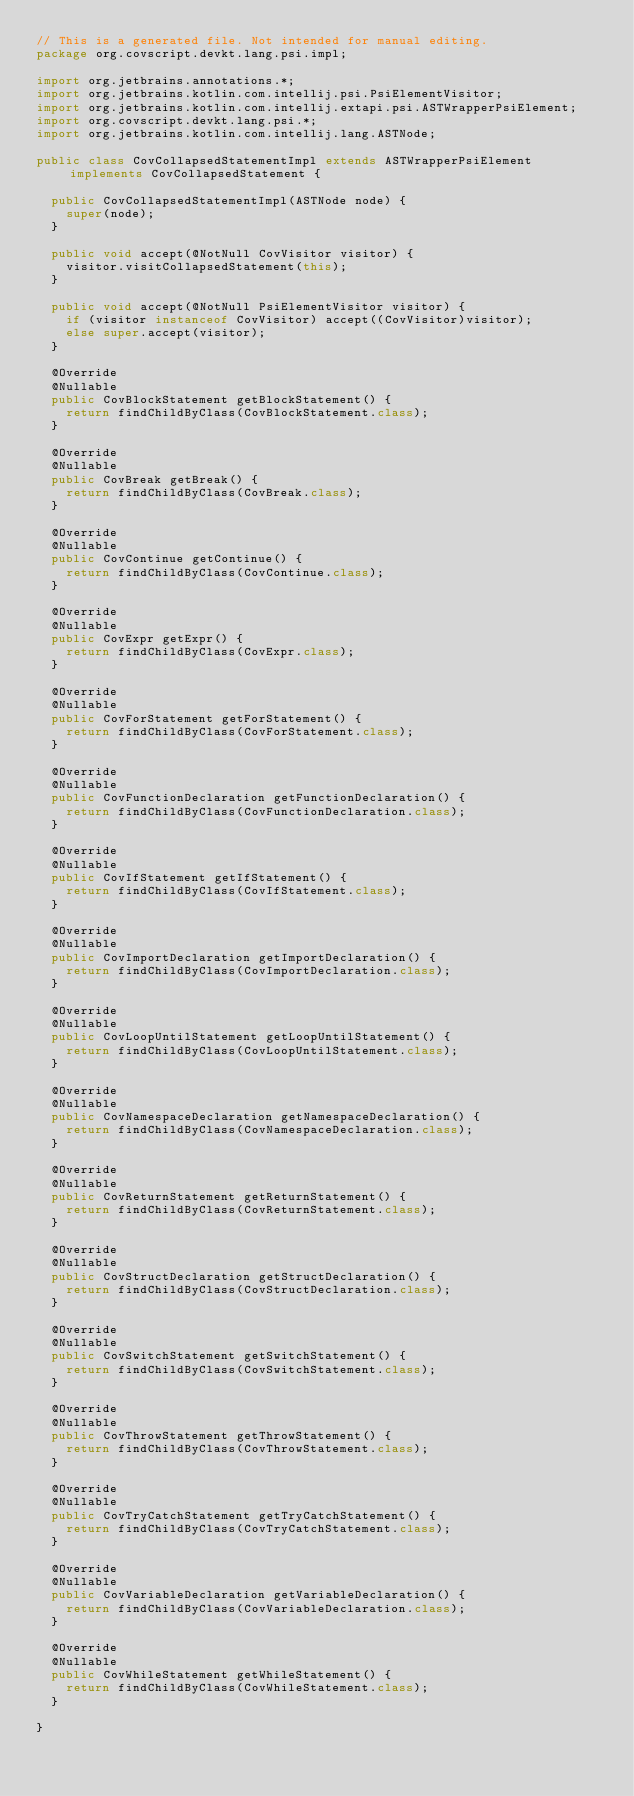Convert code to text. <code><loc_0><loc_0><loc_500><loc_500><_Java_>// This is a generated file. Not intended for manual editing.
package org.covscript.devkt.lang.psi.impl;

import org.jetbrains.annotations.*;
import org.jetbrains.kotlin.com.intellij.psi.PsiElementVisitor;
import org.jetbrains.kotlin.com.intellij.extapi.psi.ASTWrapperPsiElement;
import org.covscript.devkt.lang.psi.*;
import org.jetbrains.kotlin.com.intellij.lang.ASTNode;

public class CovCollapsedStatementImpl extends ASTWrapperPsiElement implements CovCollapsedStatement {

  public CovCollapsedStatementImpl(ASTNode node) {
    super(node);
  }

  public void accept(@NotNull CovVisitor visitor) {
    visitor.visitCollapsedStatement(this);
  }

  public void accept(@NotNull PsiElementVisitor visitor) {
    if (visitor instanceof CovVisitor) accept((CovVisitor)visitor);
    else super.accept(visitor);
  }

  @Override
  @Nullable
  public CovBlockStatement getBlockStatement() {
    return findChildByClass(CovBlockStatement.class);
  }

  @Override
  @Nullable
  public CovBreak getBreak() {
    return findChildByClass(CovBreak.class);
  }

  @Override
  @Nullable
  public CovContinue getContinue() {
    return findChildByClass(CovContinue.class);
  }

  @Override
  @Nullable
  public CovExpr getExpr() {
    return findChildByClass(CovExpr.class);
  }

  @Override
  @Nullable
  public CovForStatement getForStatement() {
    return findChildByClass(CovForStatement.class);
  }

  @Override
  @Nullable
  public CovFunctionDeclaration getFunctionDeclaration() {
    return findChildByClass(CovFunctionDeclaration.class);
  }

  @Override
  @Nullable
  public CovIfStatement getIfStatement() {
    return findChildByClass(CovIfStatement.class);
  }

  @Override
  @Nullable
  public CovImportDeclaration getImportDeclaration() {
    return findChildByClass(CovImportDeclaration.class);
  }

  @Override
  @Nullable
  public CovLoopUntilStatement getLoopUntilStatement() {
    return findChildByClass(CovLoopUntilStatement.class);
  }

  @Override
  @Nullable
  public CovNamespaceDeclaration getNamespaceDeclaration() {
    return findChildByClass(CovNamespaceDeclaration.class);
  }

  @Override
  @Nullable
  public CovReturnStatement getReturnStatement() {
    return findChildByClass(CovReturnStatement.class);
  }

  @Override
  @Nullable
  public CovStructDeclaration getStructDeclaration() {
    return findChildByClass(CovStructDeclaration.class);
  }

  @Override
  @Nullable
  public CovSwitchStatement getSwitchStatement() {
    return findChildByClass(CovSwitchStatement.class);
  }

  @Override
  @Nullable
  public CovThrowStatement getThrowStatement() {
    return findChildByClass(CovThrowStatement.class);
  }

  @Override
  @Nullable
  public CovTryCatchStatement getTryCatchStatement() {
    return findChildByClass(CovTryCatchStatement.class);
  }

  @Override
  @Nullable
  public CovVariableDeclaration getVariableDeclaration() {
    return findChildByClass(CovVariableDeclaration.class);
  }

  @Override
  @Nullable
  public CovWhileStatement getWhileStatement() {
    return findChildByClass(CovWhileStatement.class);
  }

}
</code> 